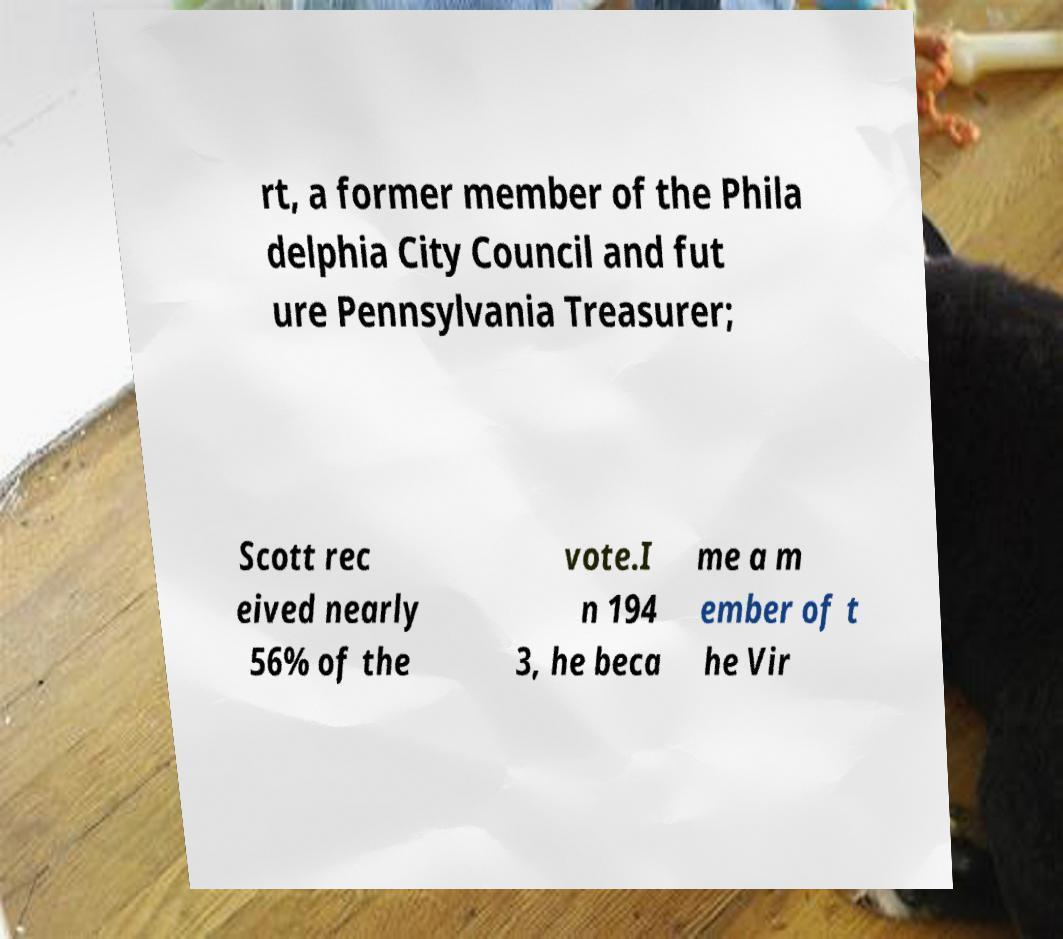What messages or text are displayed in this image? I need them in a readable, typed format. rt, a former member of the Phila delphia City Council and fut ure Pennsylvania Treasurer; Scott rec eived nearly 56% of the vote.I n 194 3, he beca me a m ember of t he Vir 